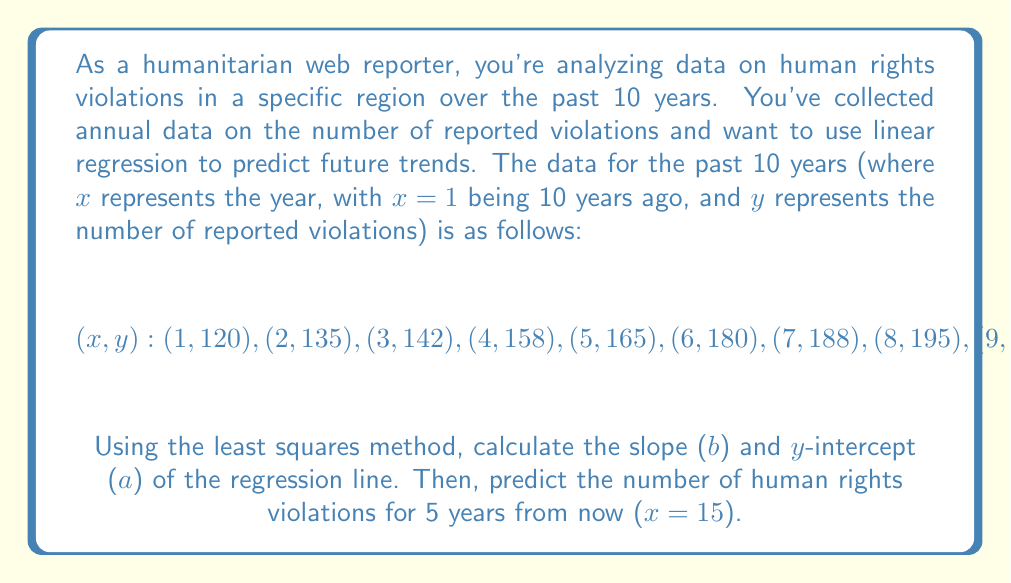Show me your answer to this math problem. To perform linear regression using the least squares method, we need to calculate the slope (b) and y-intercept (a) of the line y = a + bx.

Step 1: Calculate the means of x and y
$$\bar{x} = \frac{\sum x}{n} = \frac{1 + 2 + 3 + ... + 10}{10} = 5.5$$
$$\bar{y} = \frac{\sum y}{n} = \frac{120 + 135 + 142 + ... + 225}{10} = 171.8$$

Step 2: Calculate the slope (b)
$$b = \frac{\sum (x - \bar{x})(y - \bar{y})}{\sum (x - \bar{x})^2}$$

To calculate this, we need to compute the following sums:
$$\sum (x - \bar{x})(y - \bar{y}) = 1650.5$$
$$\sum (x - \bar{x})^2 = 82.5$$

Thus, $$b = \frac{1650.5}{82.5} = 20$$

Step 3: Calculate the y-intercept (a)
$$a = \bar{y} - b\bar{x} = 171.8 - 20(5.5) = 61.8$$

Therefore, the regression line equation is:
$$y = 61.8 + 20x$$

Step 4: Predict the number of violations for 5 years from now (x = 15)
$$y = 61.8 + 20(15) = 361.8$$

Rounding to the nearest whole number, we predict 362 human rights violations 5 years from now.
Answer: The regression line equation is $y = 61.8 + 20x$, and the predicted number of human rights violations 5 years from now (x = 15) is 362. 